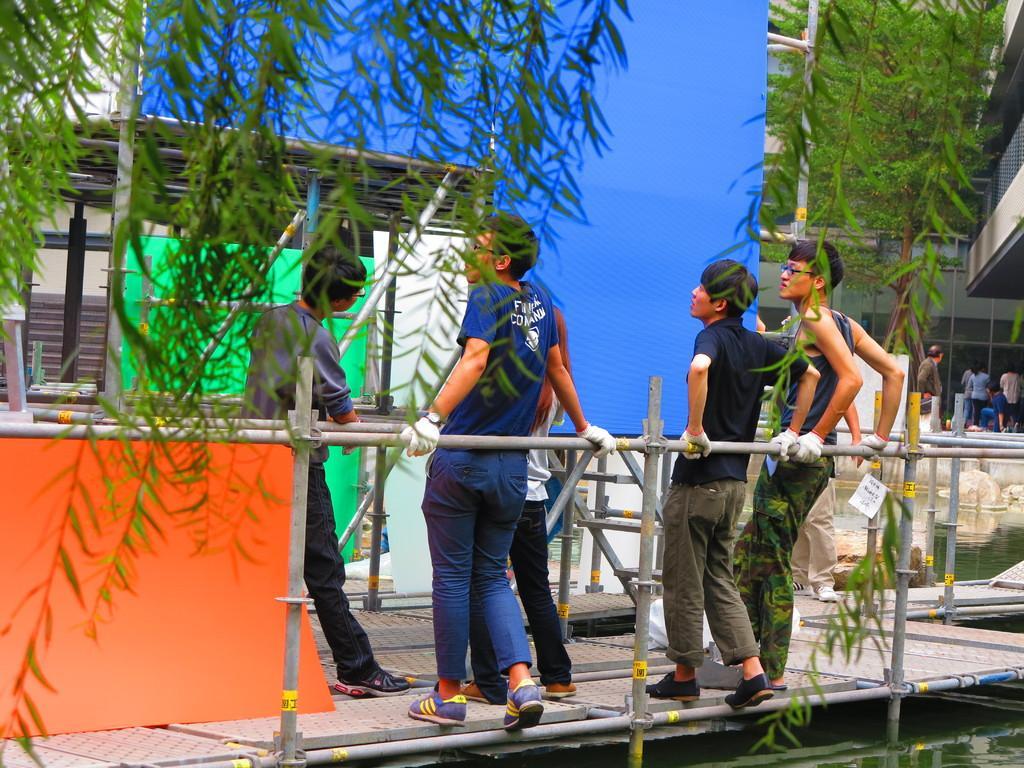In one or two sentences, can you explain what this image depicts? In this picture there are people and we can see poles, trees, watershed, buildings and objects. 